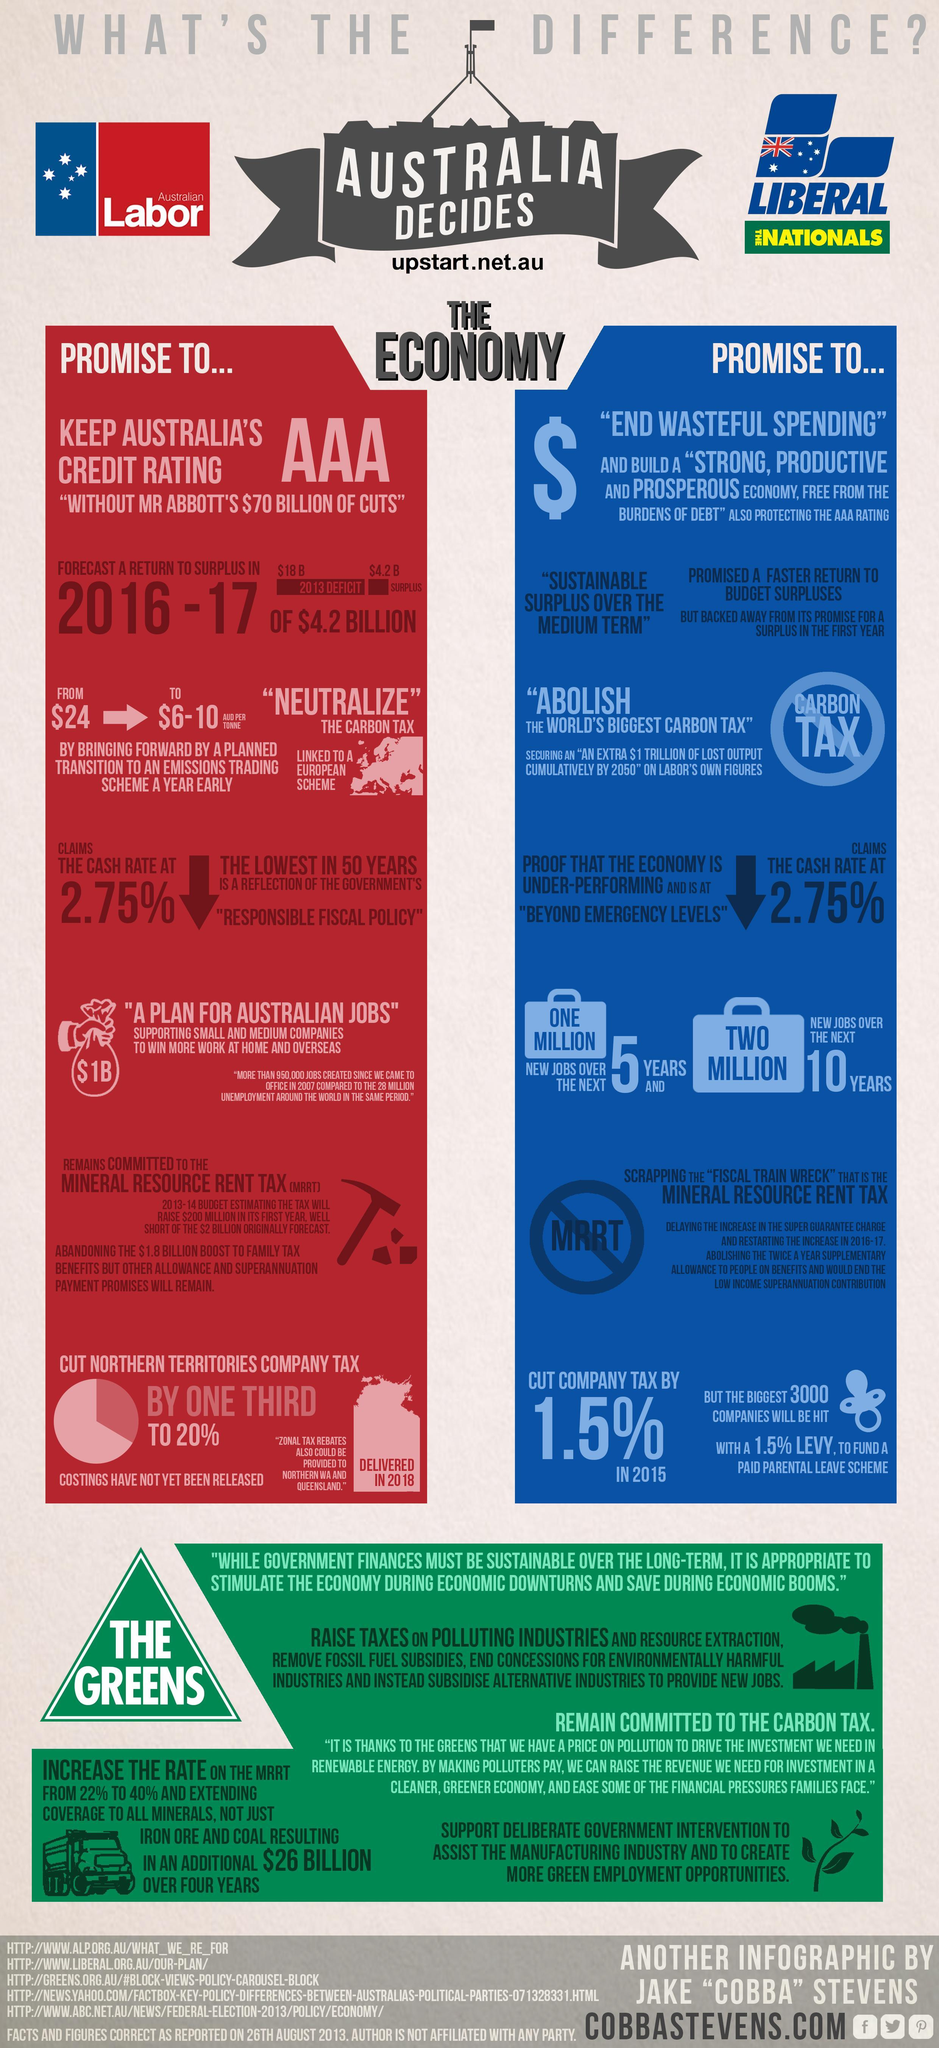Which color represents the promises of Australian Labor, Red or blue?
Answer the question with a short phrase. red Which color represents the promises of Liberal nationals, Red or blue? blue 